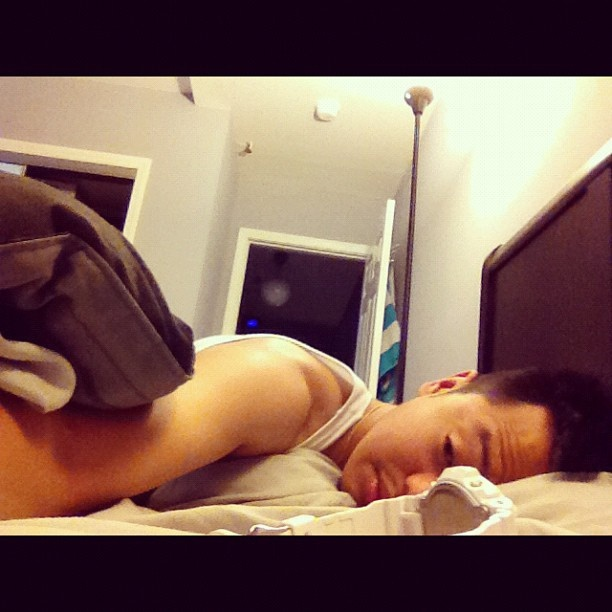Describe the objects in this image and their specific colors. I can see bed in black, maroon, tan, and brown tones and people in black, brown, tan, and maroon tones in this image. 